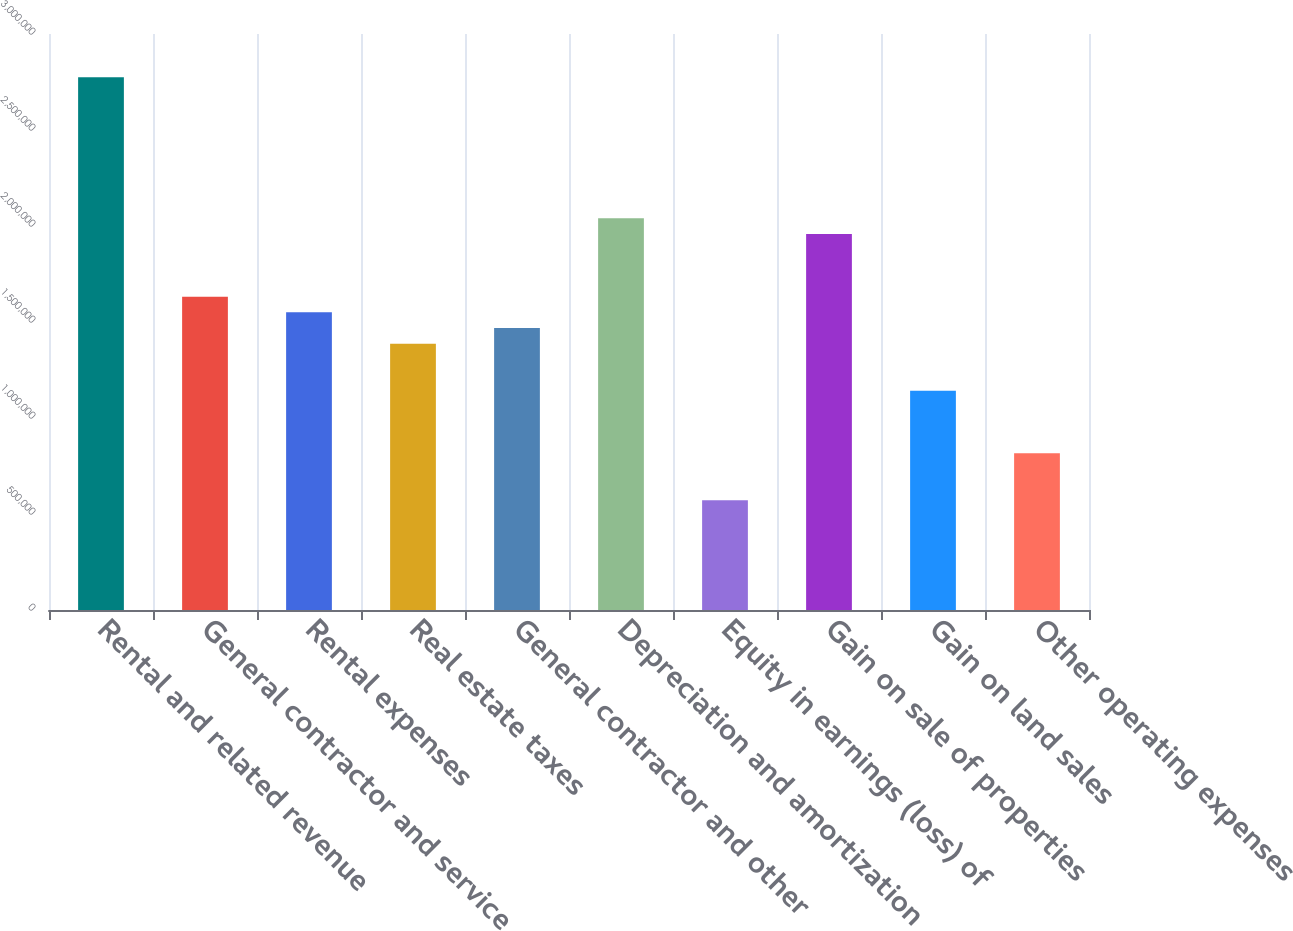Convert chart to OTSL. <chart><loc_0><loc_0><loc_500><loc_500><bar_chart><fcel>Rental and related revenue<fcel>General contractor and service<fcel>Rental expenses<fcel>Real estate taxes<fcel>General contractor and other<fcel>Depreciation and amortization<fcel>Equity in earnings (loss) of<fcel>Gain on sale of properties<fcel>Gain on land sales<fcel>Other operating expenses<nl><fcel>2.77462e+06<fcel>1.63213e+06<fcel>1.55052e+06<fcel>1.38731e+06<fcel>1.46892e+06<fcel>2.04016e+06<fcel>571246<fcel>1.95856e+06<fcel>1.14249e+06<fcel>816065<nl></chart> 